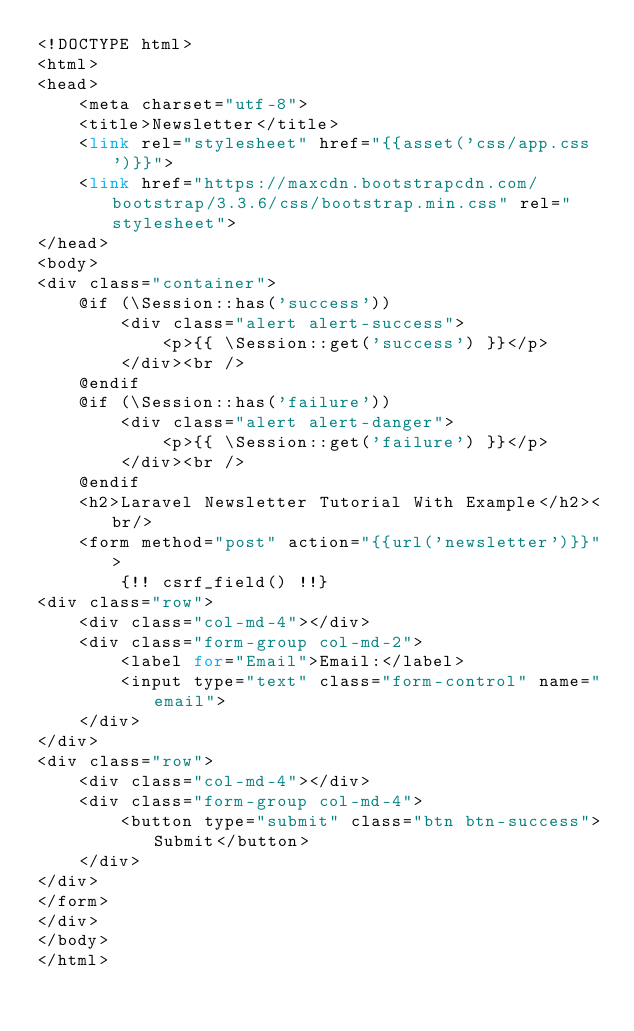<code> <loc_0><loc_0><loc_500><loc_500><_PHP_><!DOCTYPE html>
<html>
<head>
    <meta charset="utf-8">
    <title>Newsletter</title>
    <link rel="stylesheet" href="{{asset('css/app.css')}}">
    <link href="https://maxcdn.bootstrapcdn.com/bootstrap/3.3.6/css/bootstrap.min.css" rel="stylesheet">
</head>
<body>
<div class="container">
    @if (\Session::has('success'))
        <div class="alert alert-success">
            <p>{{ \Session::get('success') }}</p>
        </div><br />
    @endif
    @if (\Session::has('failure'))
        <div class="alert alert-danger">
            <p>{{ \Session::get('failure') }}</p>
        </div><br />
    @endif
    <h2>Laravel Newsletter Tutorial With Example</h2><br/>
    <form method="post" action="{{url('newsletter')}}">
        {!! csrf_field() !!}
<div class="row">
    <div class="col-md-4"></div>
    <div class="form-group col-md-2">
        <label for="Email">Email:</label>
        <input type="text" class="form-control" name="email">
    </div>
</div>
<div class="row">
    <div class="col-md-4"></div>
    <div class="form-group col-md-4">
        <button type="submit" class="btn btn-success">Submit</button>
    </div>
</div>
</form>
</div>
</body>
</html></code> 